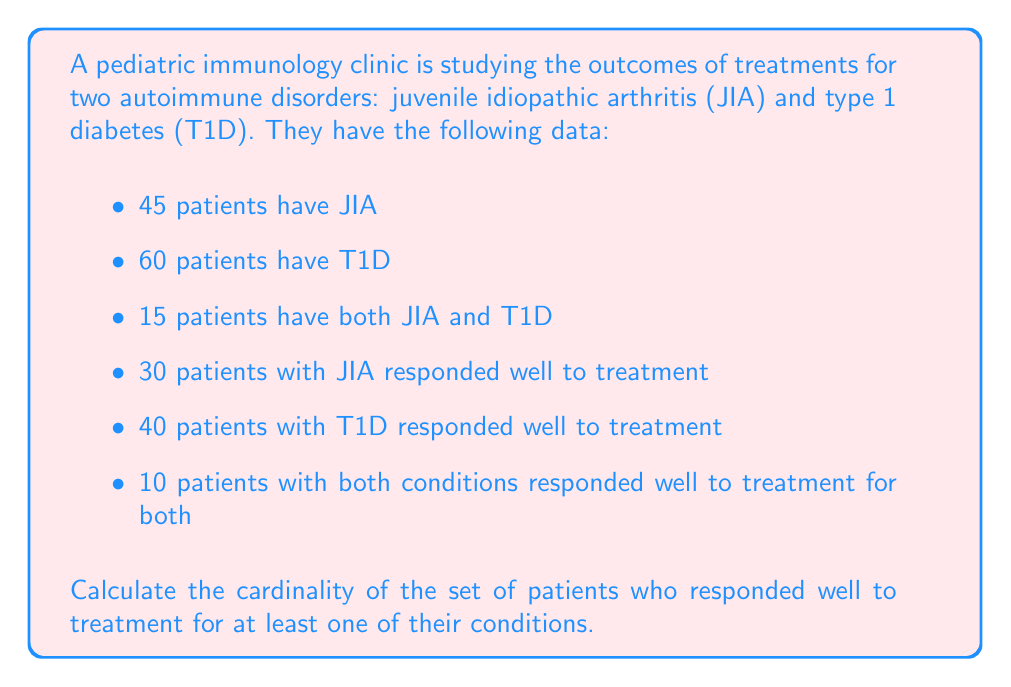Help me with this question. Let's approach this step-by-step using set theory:

1) Let J be the set of patients with JIA, and T be the set of patients with T1D.

2) We're given:
   $|J| = 45$
   $|T| = 60$
   $|J \cap T| = 15$

3) Let R be the set of patients who responded well to treatment for at least one condition.

4) We can split R into three disjoint subsets:
   - R_J: Patients who responded well to JIA treatment only
   - R_T: Patients who responded well to T1D treatment only
   - R_B: Patients who responded well to both treatments

5) We're given:
   $|R_J \cup R_B| = 30$
   $|R_T \cup R_B| = 40$
   $|R_B| = 10$

6) We can calculate:
   $|R_J| = 30 - 10 = 20$
   $|R_T| = 40 - 10 = 30$

7) Now, we can use the principle of inclusion-exclusion:
   $|R| = |R_J| + |R_T| + |R_B|$

8) Substituting the values:
   $|R| = 20 + 30 + 10 = 60$

Therefore, the cardinality of the set of patients who responded well to treatment for at least one of their conditions is 60.
Answer: 60 